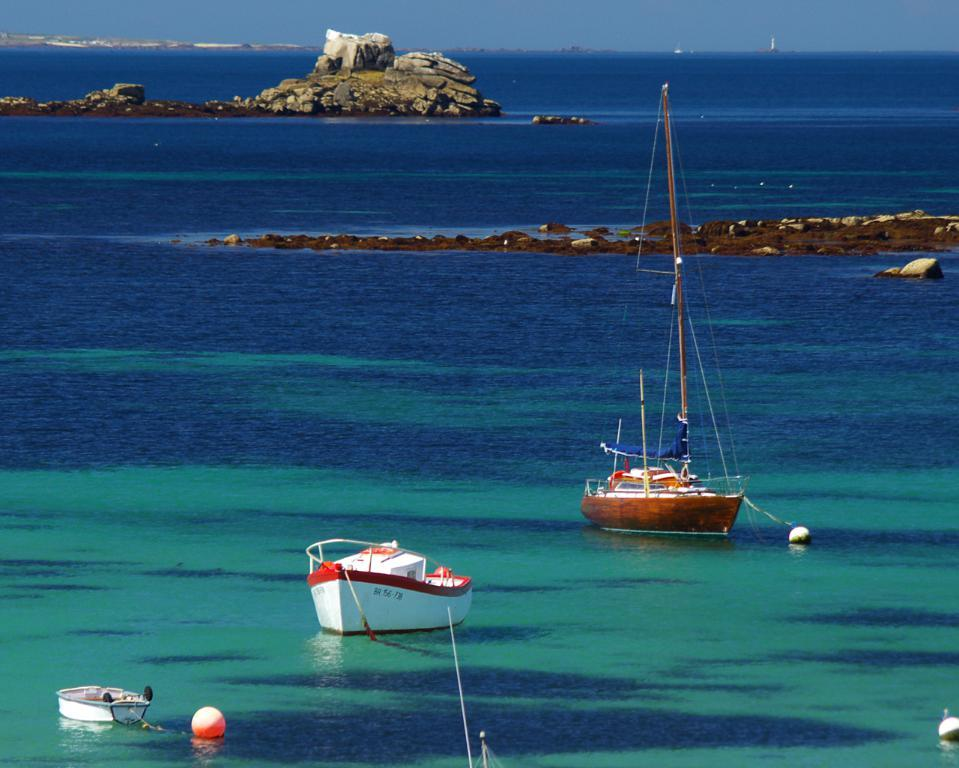What is the main subject of the image? The main subject of the image is a ship. Where is the ship located in the image? The ship is on the water surface in the image. What type of landscape can be seen in the background? There are hills visible in the image. What else can be seen in the image besides the ship and hills? There are other objects in the image. What is visible at the top of the image? The sky is visible at the top of the image. How many jellyfish are swimming near the ship in the image? There are no jellyfish present in the image; it features a ship on the water surface with hills and other objects in the background. What word is written on the side of the ship in the image? There is no word visible on the side of the ship in the image. 